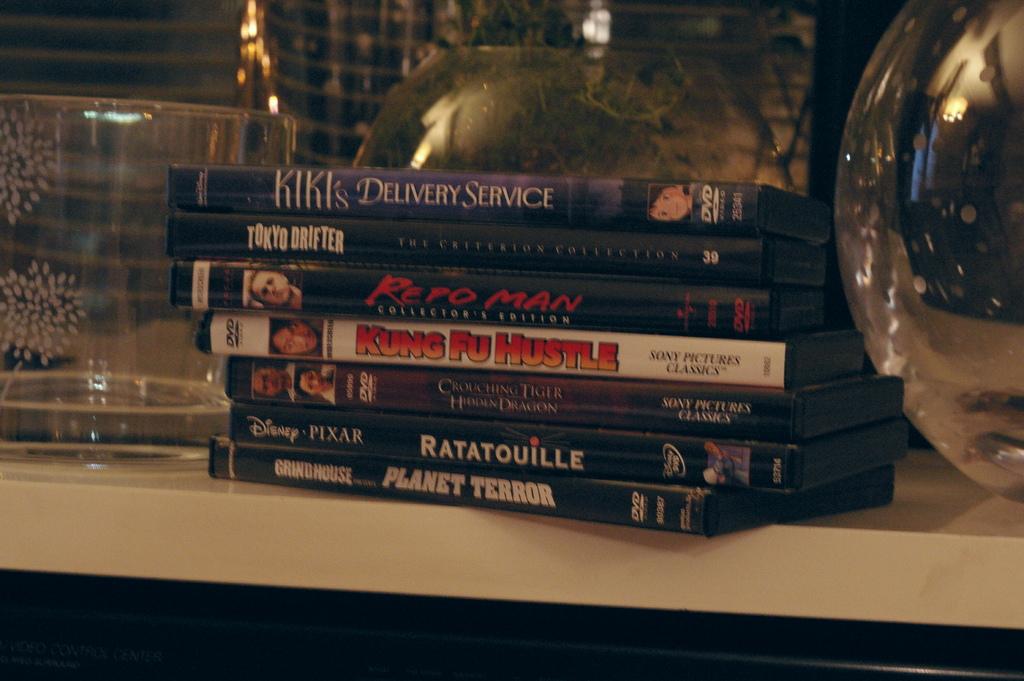What is the name of the movie with the white cover?
Offer a terse response. Kung fu hustle. 